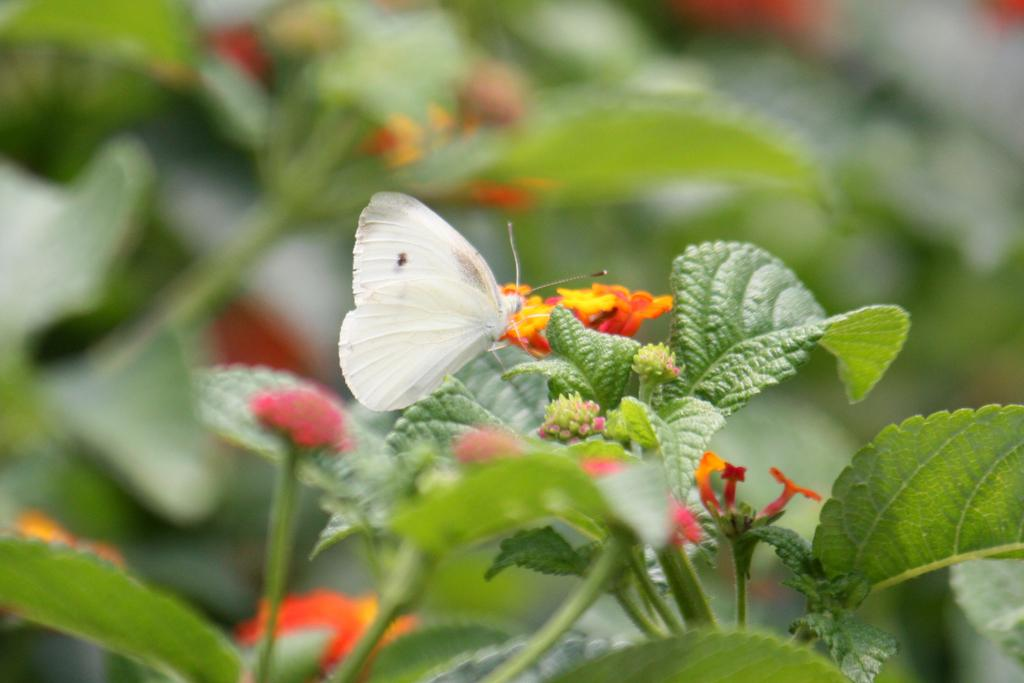What is the main subject of the image? There is a butterfly on a leaf in the image. What other elements can be seen in the image? There are plants and flowers in the image. How would you describe the background of the image? The background of the image is blurred. What type of sand can be seen in the image? There is no sand present in the image. How does the butterfly act when it sneezes in the image? Butterflies do not sneeze, and there is no indication that the butterfly in the image is sneezing. 